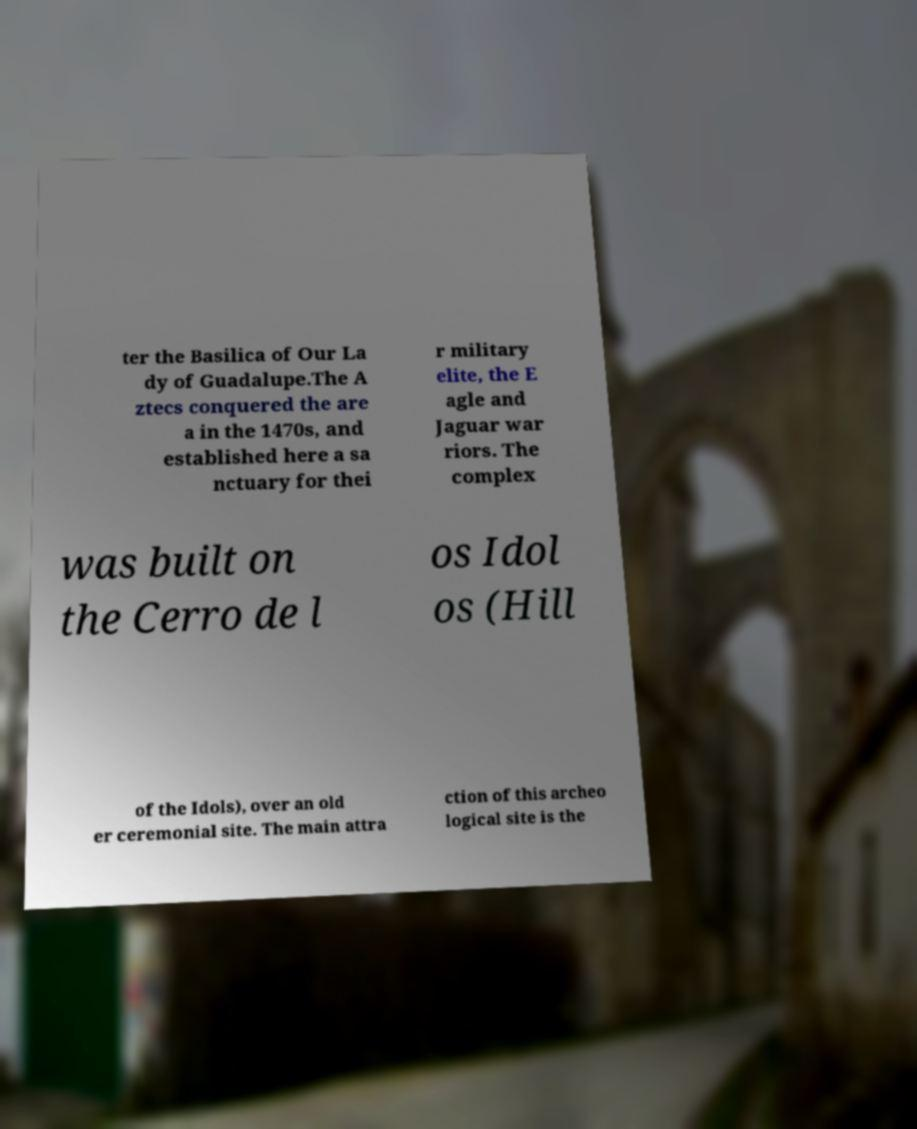Can you read and provide the text displayed in the image?This photo seems to have some interesting text. Can you extract and type it out for me? ter the Basilica of Our La dy of Guadalupe.The A ztecs conquered the are a in the 1470s, and established here a sa nctuary for thei r military elite, the E agle and Jaguar war riors. The complex was built on the Cerro de l os Idol os (Hill of the Idols), over an old er ceremonial site. The main attra ction of this archeo logical site is the 